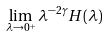<formula> <loc_0><loc_0><loc_500><loc_500>\lim _ { \lambda \to 0 ^ { + } } \lambda ^ { - 2 \gamma } H ( \lambda )</formula> 